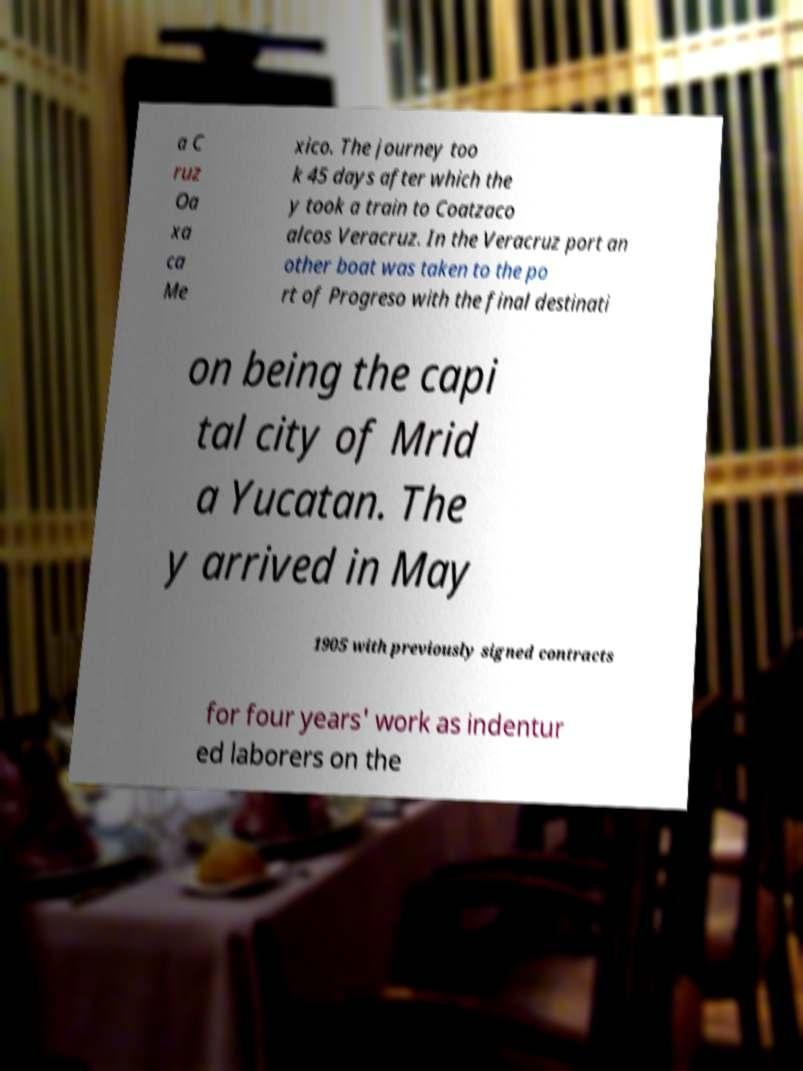I need the written content from this picture converted into text. Can you do that? a C ruz Oa xa ca Me xico. The journey too k 45 days after which the y took a train to Coatzaco alcos Veracruz. In the Veracruz port an other boat was taken to the po rt of Progreso with the final destinati on being the capi tal city of Mrid a Yucatan. The y arrived in May 1905 with previously signed contracts for four years' work as indentur ed laborers on the 